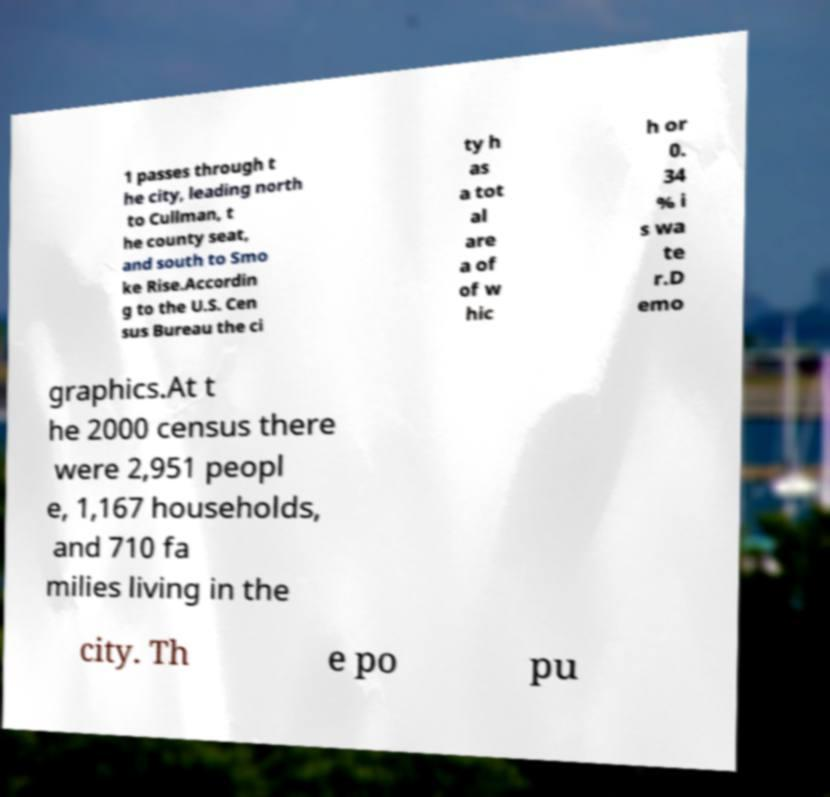Please identify and transcribe the text found in this image. 1 passes through t he city, leading north to Cullman, t he county seat, and south to Smo ke Rise.Accordin g to the U.S. Cen sus Bureau the ci ty h as a tot al are a of of w hic h or 0. 34 % i s wa te r.D emo graphics.At t he 2000 census there were 2,951 peopl e, 1,167 households, and 710 fa milies living in the city. Th e po pu 